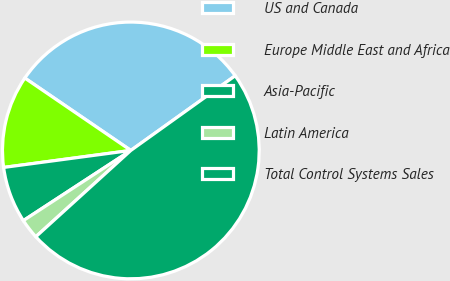Convert chart to OTSL. <chart><loc_0><loc_0><loc_500><loc_500><pie_chart><fcel>US and Canada<fcel>Europe Middle East and Africa<fcel>Asia-Pacific<fcel>Latin America<fcel>Total Control Systems Sales<nl><fcel>30.58%<fcel>11.65%<fcel>7.09%<fcel>2.53%<fcel>48.15%<nl></chart> 